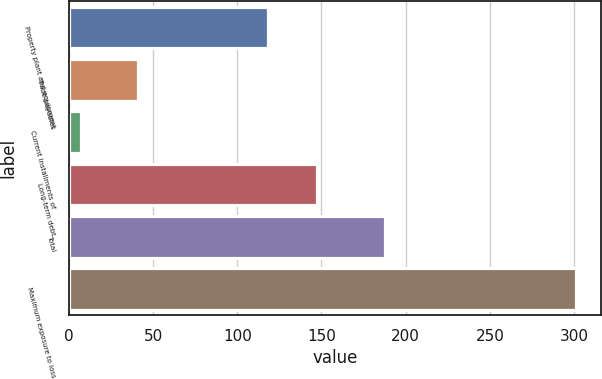<chart> <loc_0><loc_0><loc_500><loc_500><bar_chart><fcel>Property plant and equipment<fcel>Trade payables<fcel>Current installments of<fcel>Long-term debt<fcel>Total<fcel>Maximum exposure to loss<nl><fcel>118<fcel>41<fcel>7<fcel>147.4<fcel>188<fcel>301<nl></chart> 